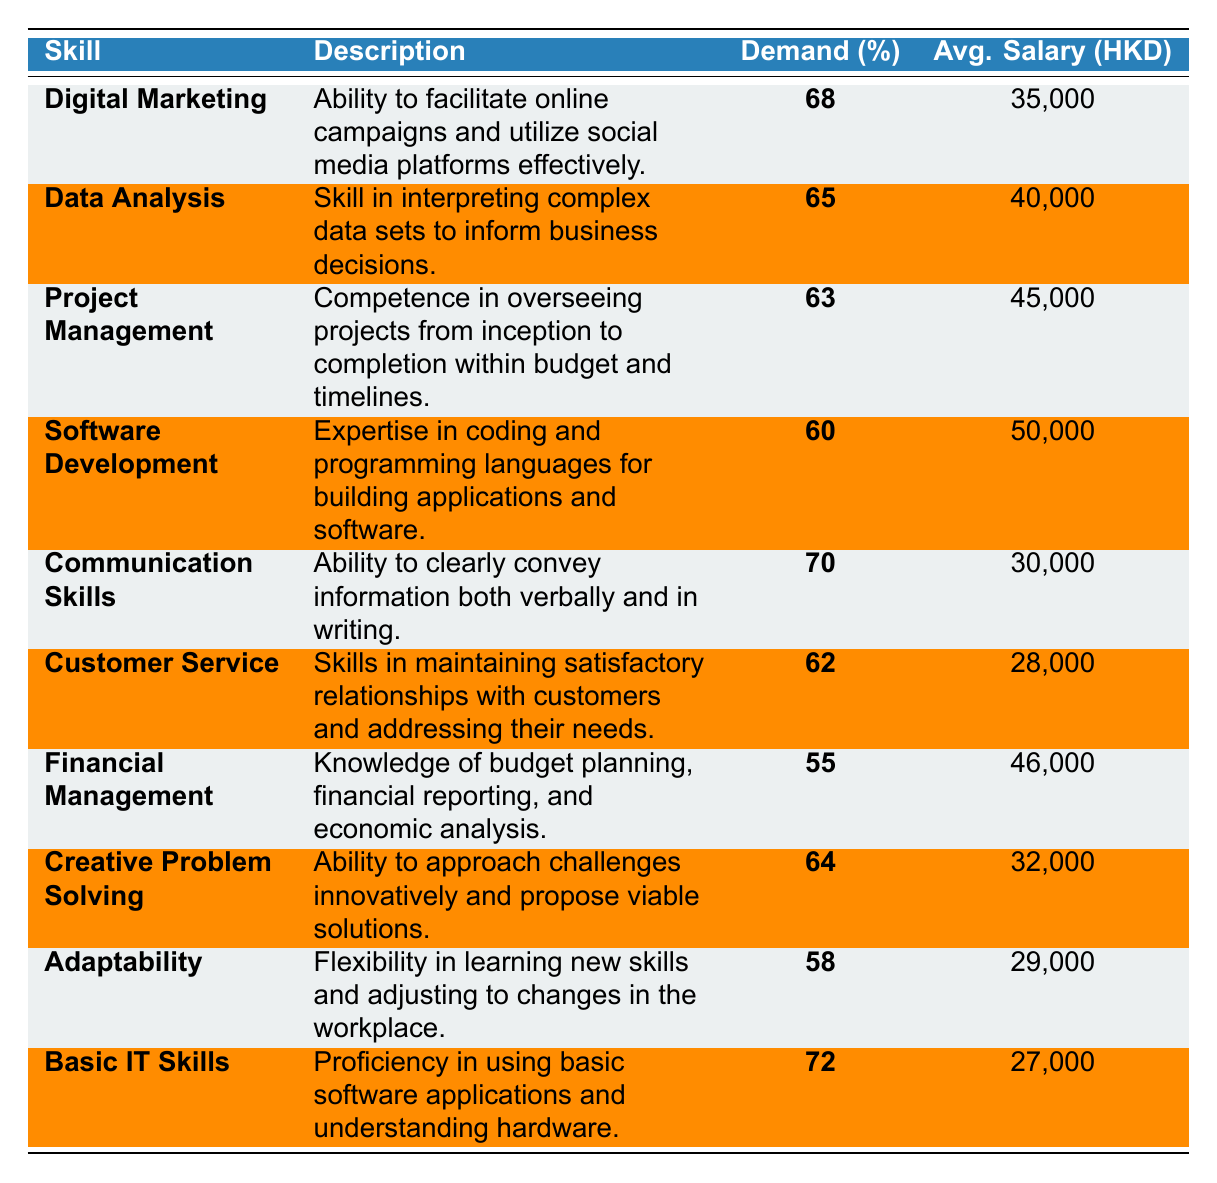What is the skill with the highest demand percentage? By reviewing the demand percentages listed in the table, Digital Marketing has the highest demand percentage at 68%.
Answer: Digital Marketing Which skill has the highest average salary? Examining the average salaries, Software Development has the highest average salary of 50,000 HKD.
Answer: Software Development Is the demand for Basic IT Skills higher than for Financial Management? Basic IT Skills has a demand percentage of 72%, whereas Financial Management has a demand percentage of 55%, making the statement true.
Answer: Yes What is the average salary of skills with a demand percentage above 60%? The skills with a demand percentage above 60% are Digital Marketing (35,000), Data Analysis (40,000), Project Management (45,000), Communication Skills (30,000), Customer Service (28,000), and Creative Problem Solving (32,000). The total salary is 35,000 + 40,000 + 45,000 + 30,000 + 28,000 + 32,000 = 210,000 HKD, and there are 6 skills. Therefore, the average salary is 210,000 / 6 = 35,000 HKD.
Answer: 35,000 Which two skills have similar demand percentage and how do their average salaries compare? Looking at the demand percentages, Project Management (63%) and Customer Service (62%) have similar demand percentages. Their average salaries are 45,000 HKD and 28,000 HKD, respectively, with Project Management having a higher salary.
Answer: Project Management and Customer Service; Project Management is higher What percentage of the skills listed have an average salary below 30,000 HKD? The skills below 30,000 HKD are Customer Service (28,000) and Basic IT Skills (27,000). There are 10 skills total, so 2 out of 10 is 20%.
Answer: 20% What is the total demand percentage of the top three skills? The top three skills are Communication Skills (70), Basic IT Skills (72), and Digital Marketing (68). Adding these gives 70 + 72 + 68 = 210.
Answer: 210 If adaptability increases by 10% in demand, what will be its new demand percentage and does it surpass project management? Adaptability currently has a demand percentage of 58%. Increasing this by 10% gives us 68%. Project Management has a demand of 63%, thus the new Adaptability percentage will be less than Project Management.
Answer: No 